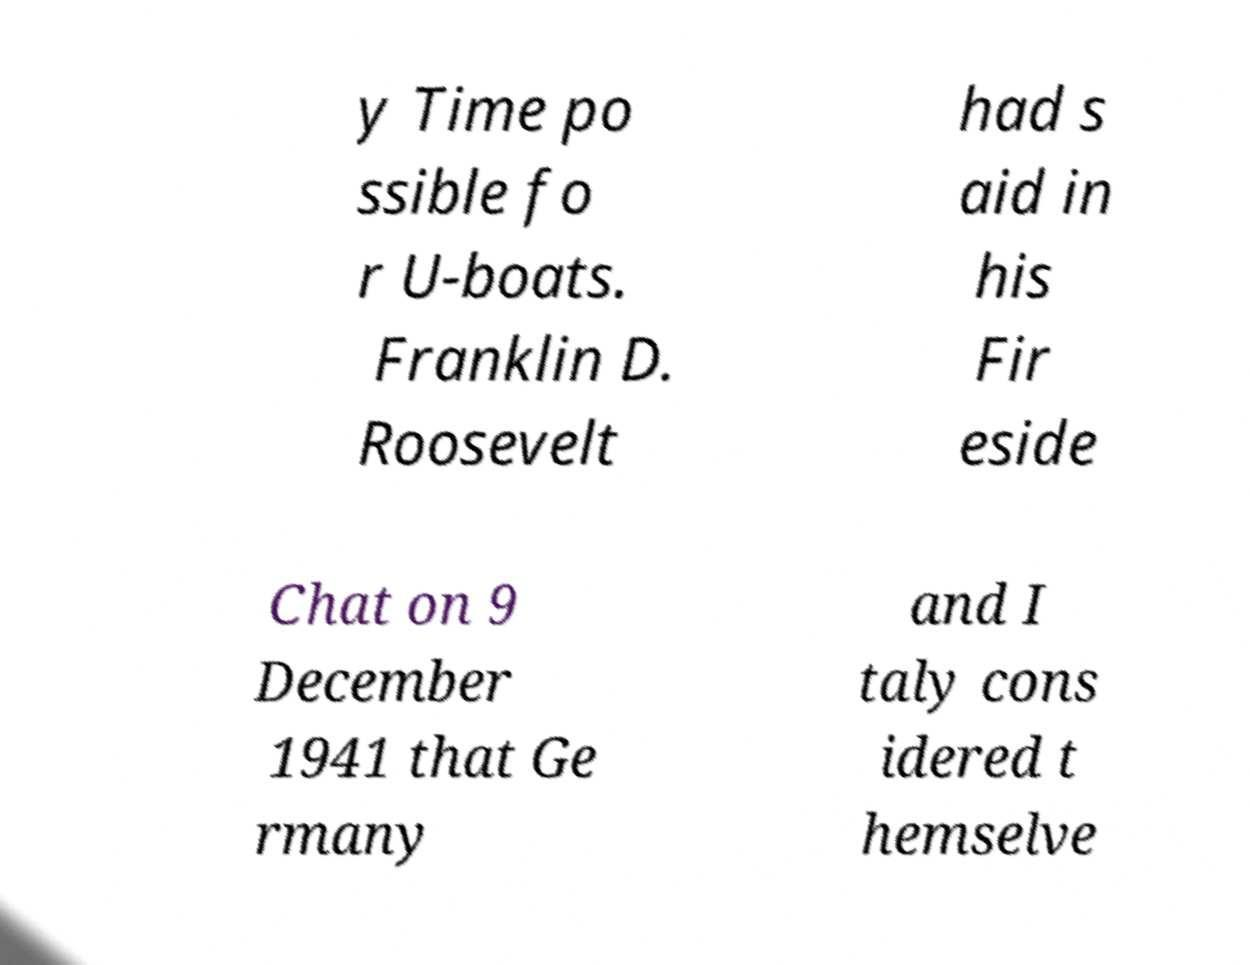Please identify and transcribe the text found in this image. y Time po ssible fo r U-boats. Franklin D. Roosevelt had s aid in his Fir eside Chat on 9 December 1941 that Ge rmany and I taly cons idered t hemselve 